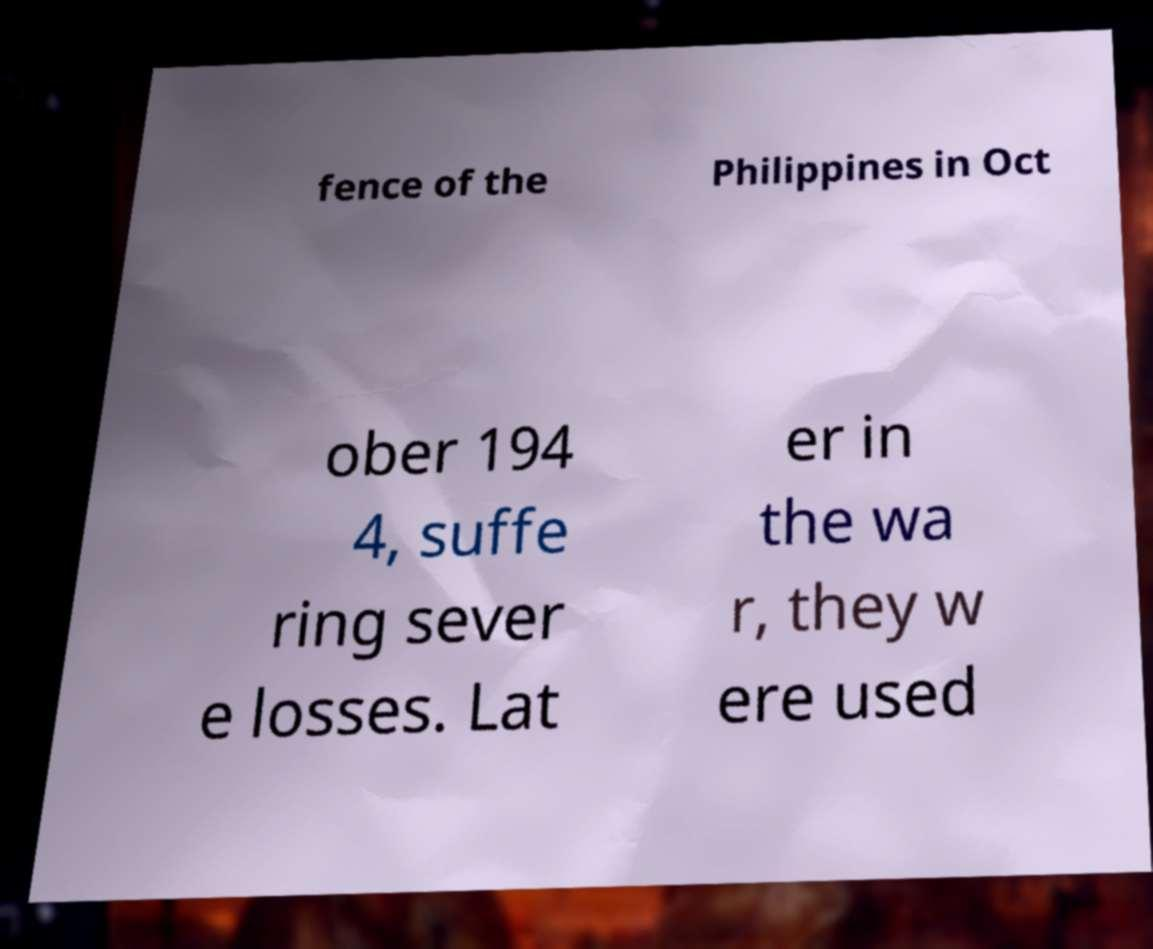What messages or text are displayed in this image? I need them in a readable, typed format. fence of the Philippines in Oct ober 194 4, suffe ring sever e losses. Lat er in the wa r, they w ere used 